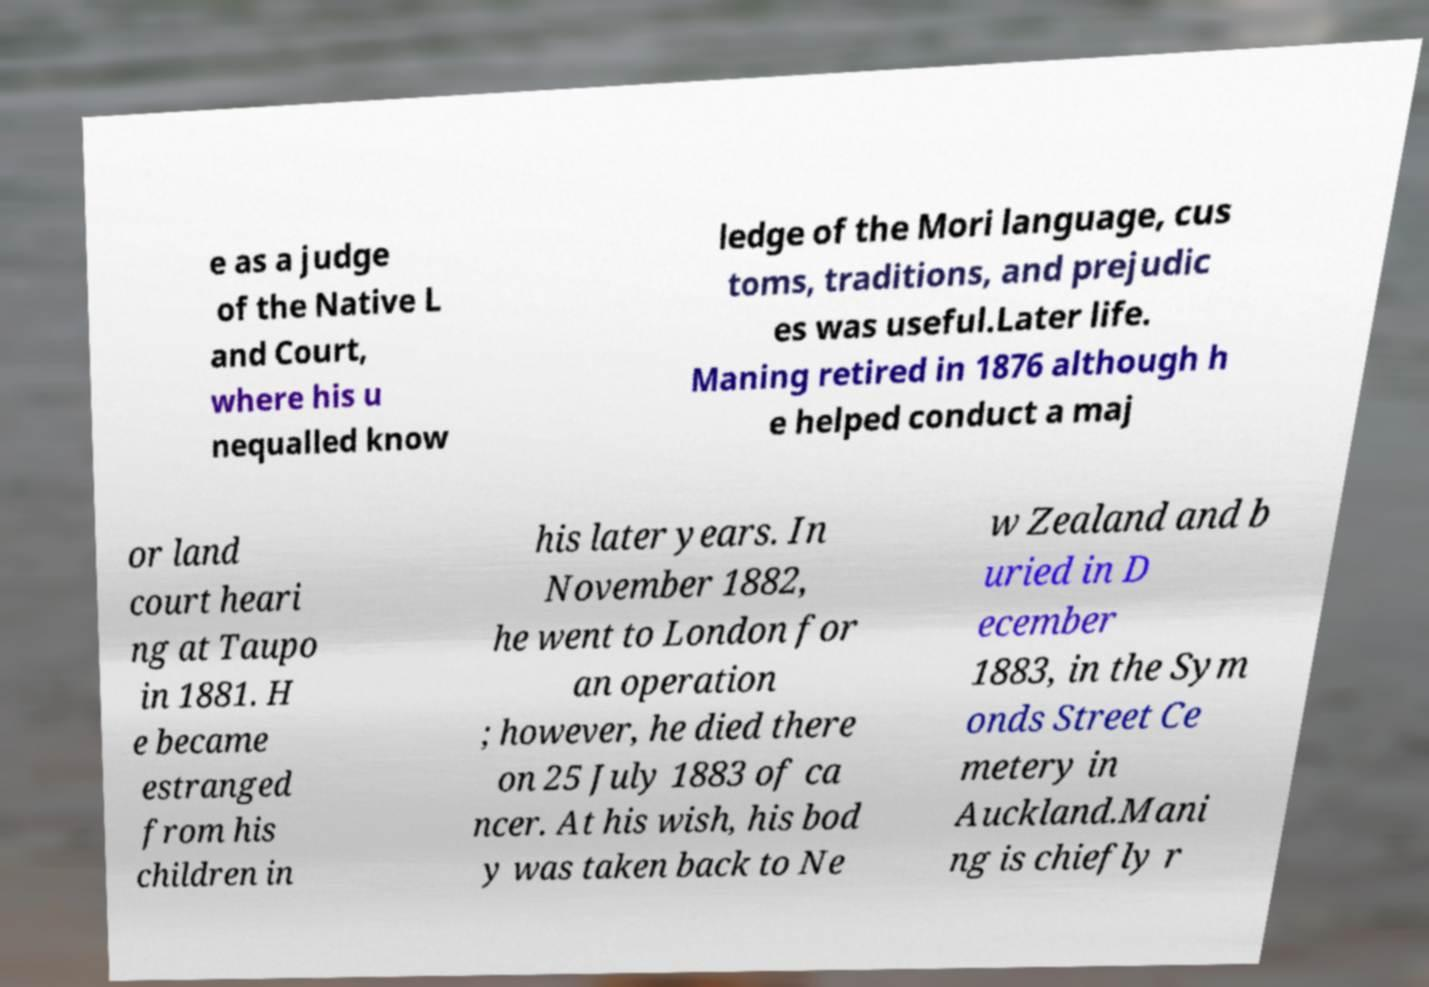Can you accurately transcribe the text from the provided image for me? e as a judge of the Native L and Court, where his u nequalled know ledge of the Mori language, cus toms, traditions, and prejudic es was useful.Later life. Maning retired in 1876 although h e helped conduct a maj or land court heari ng at Taupo in 1881. H e became estranged from his children in his later years. In November 1882, he went to London for an operation ; however, he died there on 25 July 1883 of ca ncer. At his wish, his bod y was taken back to Ne w Zealand and b uried in D ecember 1883, in the Sym onds Street Ce metery in Auckland.Mani ng is chiefly r 